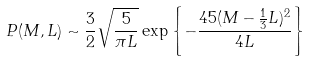Convert formula to latex. <formula><loc_0><loc_0><loc_500><loc_500>P ( M , L ) \sim \frac { 3 } { 2 } \sqrt { \frac { 5 } { \pi L } } \exp \left \{ - \frac { 4 5 ( M - \frac { 1 } { 3 } L ) ^ { 2 } } { 4 L } \right \}</formula> 